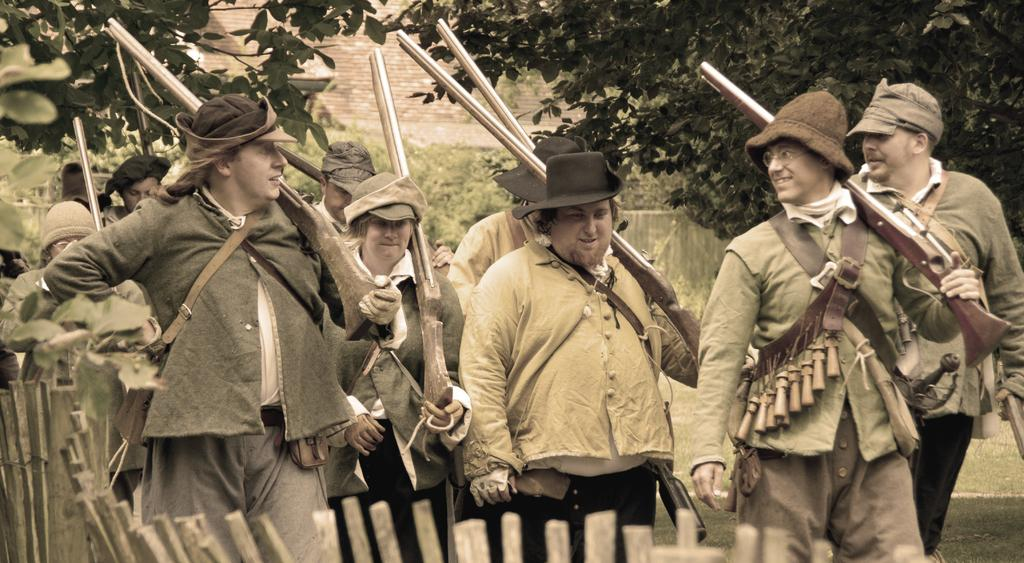What are the people in the image holding? The people in the image are holding guns. What is the terrain like in the image? The land is covered with grass. What can be seen in the background of the image? There are plants and trees in the background of the image. Can you see any mountains in the image? There are no mountains visible in the image. What type of patch is being used by the people in the image? There is no patch present in the image; the people are holding guns. 